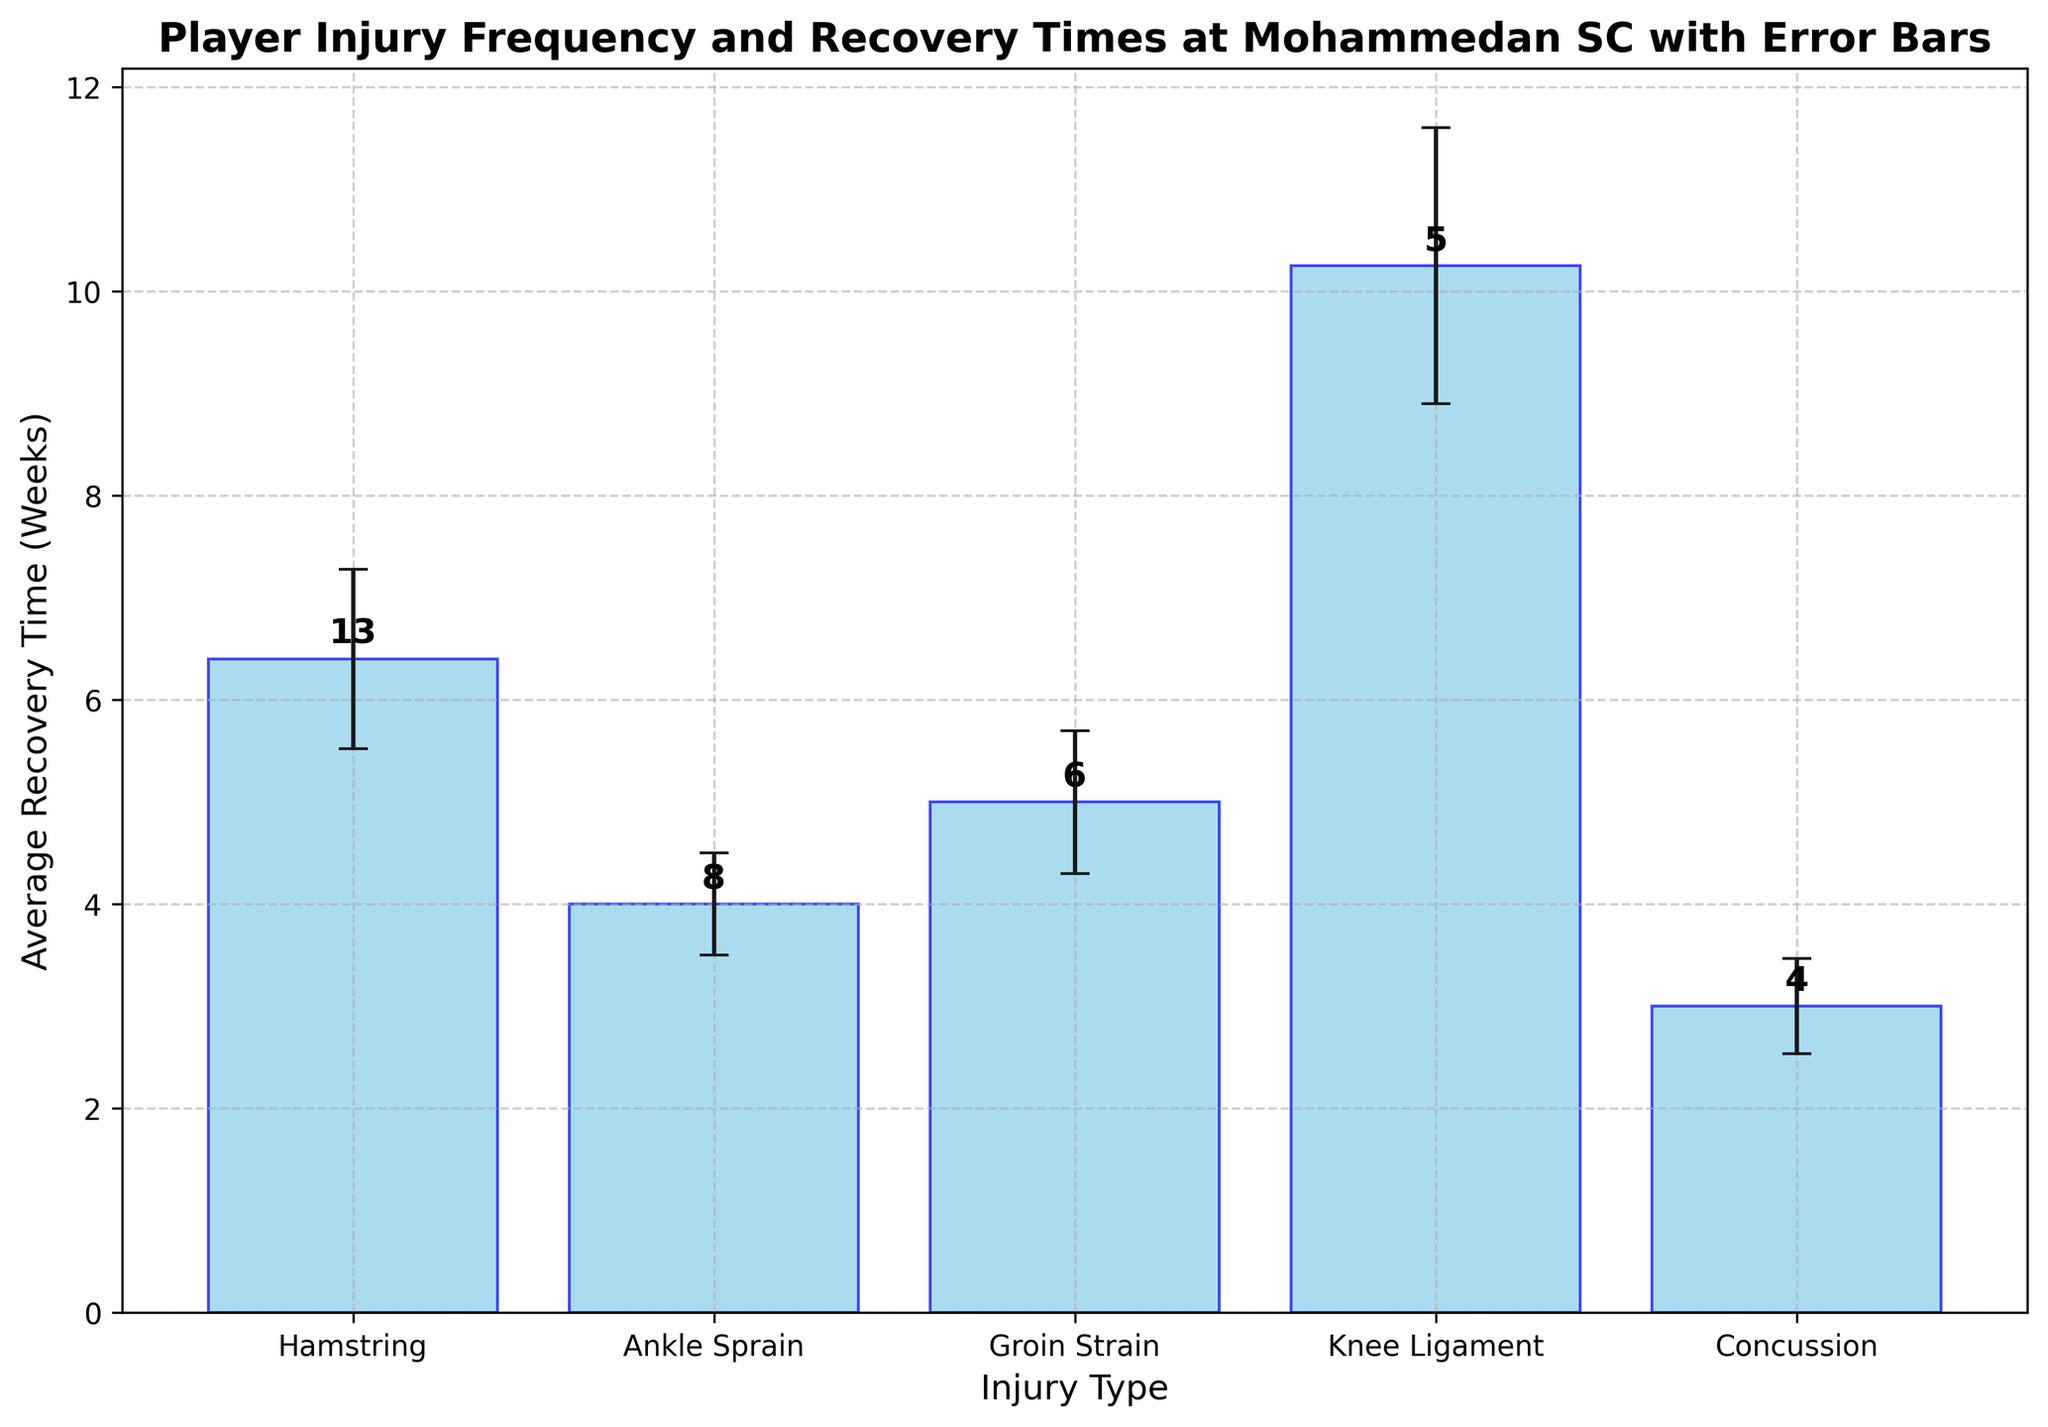Which injury type has the highest average recovery time? Looking at the the bar plot, we notice that the 'Knee Ligament' injury has the highest average recovery time compared to other injury types.
Answer: Knee Ligament Which injury type has the lowest average recovery time? By observing the bar plot, we see that 'Concussion' has the lowest average recovery time.
Answer: Concussion How many total injuries have been reported for Hamstring? Adding up the frequencies listed above the bars for Hamstring injuries, where the values are 4, 2, 3, and 1, we get 4+2+3+1=10.
Answer: 10 What is the average recovery time for Groin Strain injuries? Averaging the heights of the bars representing Groin Strain, whose individual measures are roughly 5, 6, and 4, the mean is calculated as (5+6+4)/3 = 5.
Answer: 5 Compare the frequency of 'Ankle Sprain' injuries to 'Knee Ligament' injuries. Which one is more frequent and by how much? The bar above 'Ankle Sprain' shows a total frequency of 3+1+2+2=8, while 'Knee Ligament' shows 1+2+1+1=5. Ankle Sprain is more frequent by 8-5=3 injuries.
Answer: Ankle Sprain by 3 Which injury type has the most uncertainty in recovery time? The error bars indicate uncertainty in recovery time; the longest error bar belongs to 'Knee Ligament,' indicating it has the most uncertainty.
Answer: Knee Ligament What is the total frequency of injuries for players shown in the chart? Adding the frequencies of all injury types from the bars, the result is: 10 (Hamstring) + 8 (Ankle Sprain) + 7 (Groin Strain) + 5 (Knee Ligament) + 4 (Concussion) = 34.
Answer: 34 Which injury has the smallest standard deviation in recovery time? By looking at the heights of the error bars, 'Concussion' has the smallest error bars, indicating the smallest standard deviation.
Answer: Concussion What is the difference in average recovery times between 'Hamstring' and 'Knee Ligament' injuries? Using the heights of the bars, 'Hamstring' has an average around 6 and 'Knee Ligament' around 10. The difference is 10 - 6 = 4 weeks.
Answer: 4 weeks 